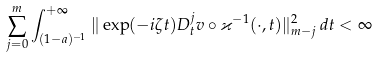Convert formula to latex. <formula><loc_0><loc_0><loc_500><loc_500>\sum _ { j = 0 } ^ { m } \int _ { ( 1 - a ) ^ { - 1 } } ^ { + \infty } \| \exp ( - i \zeta t ) D ^ { j } _ { t } v \circ \varkappa ^ { - 1 } ( \cdot , t ) \| _ { m - j } ^ { 2 } \, d t < \infty</formula> 